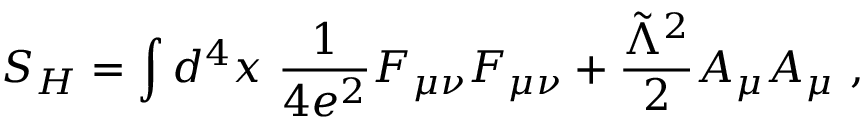Convert formula to latex. <formula><loc_0><loc_0><loc_500><loc_500>S _ { H } = \int d ^ { 4 } x \ { \frac { 1 } { 4 e ^ { 2 } } } F _ { \mu \nu } F _ { \mu \nu } + { \frac { \tilde { \Lambda } ^ { 2 } } { 2 } } A _ { \mu } A _ { \mu } \ ,</formula> 